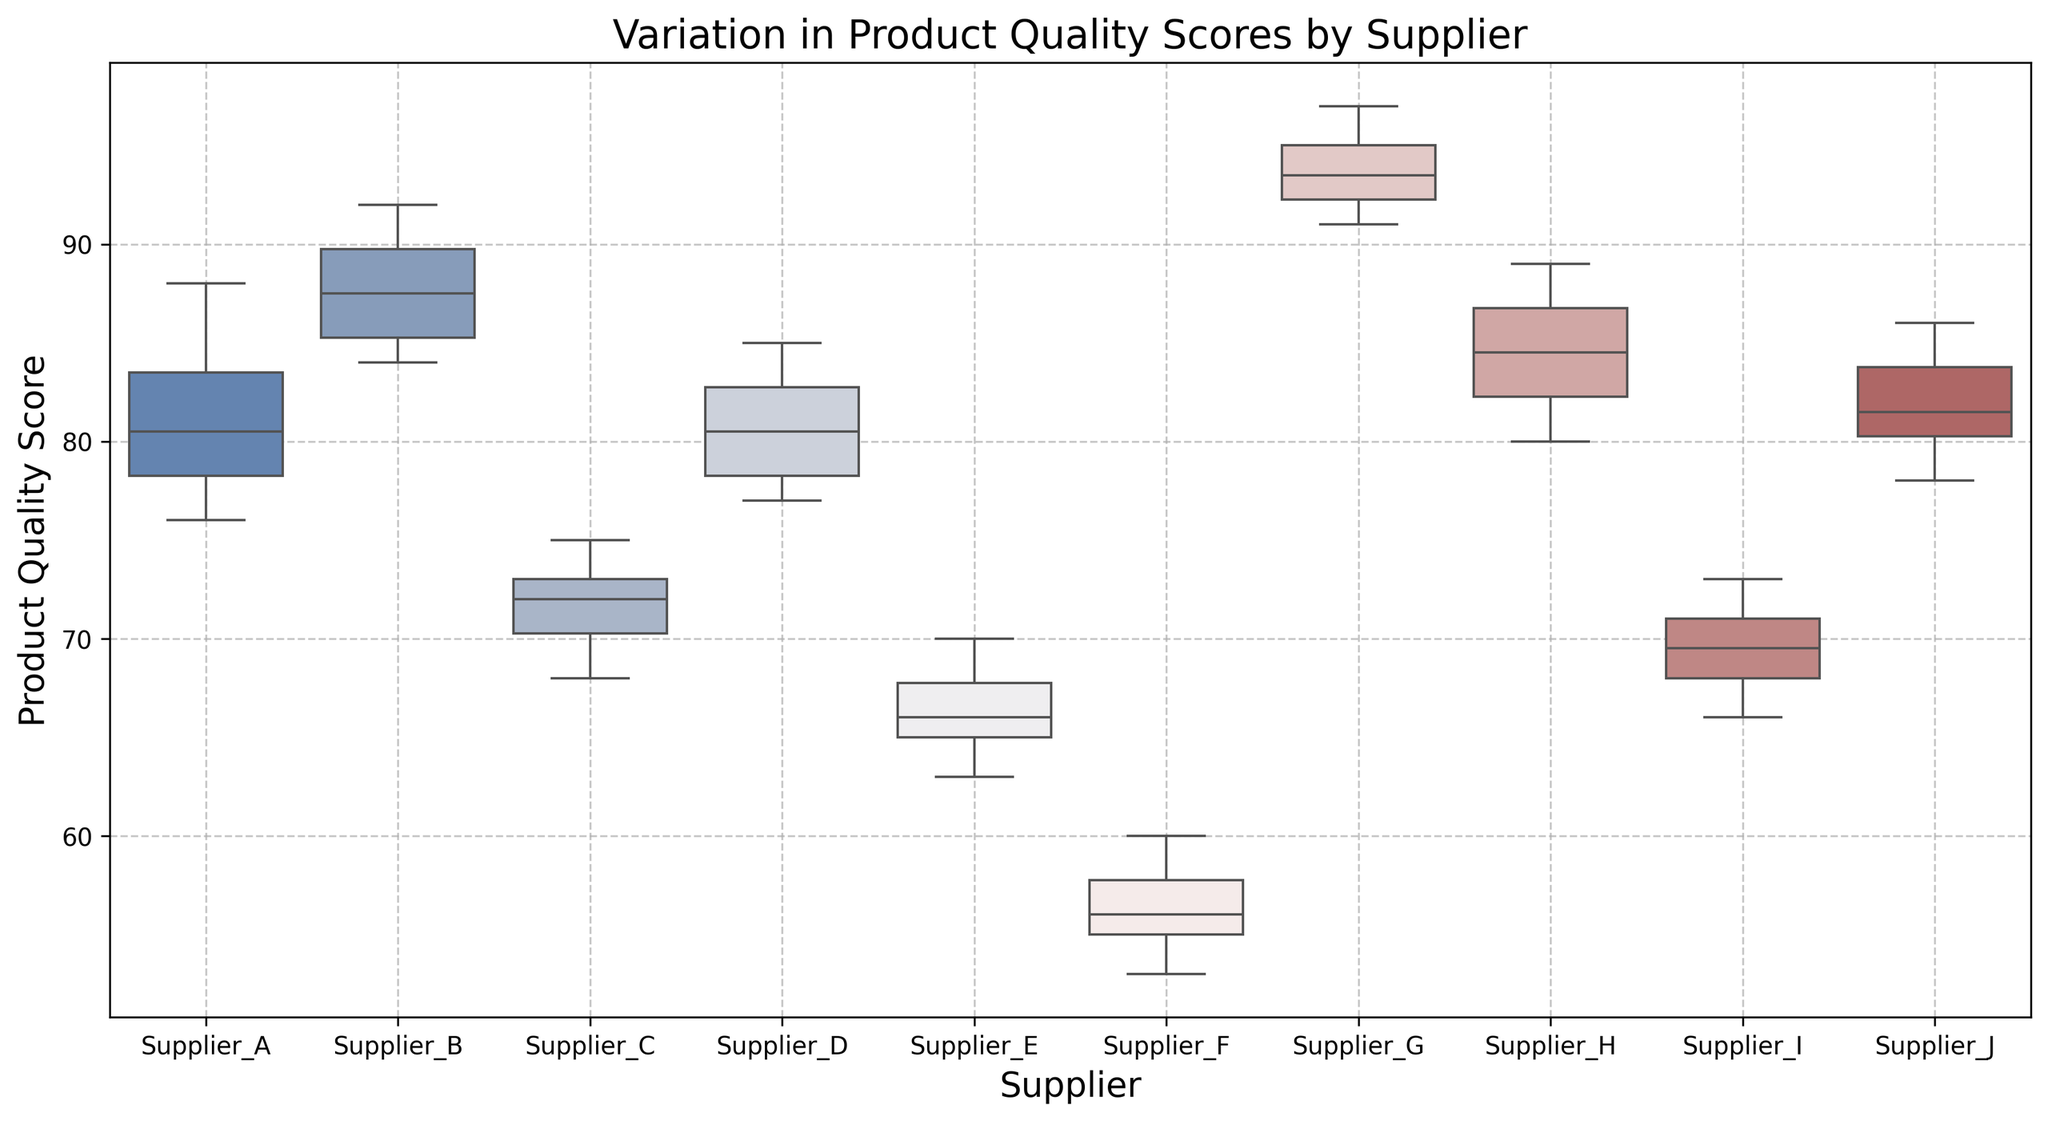Which supplier has the highest median product quality score? To find the supplier with the highest median score, look for the median lines within each box in the box plot. Supplier G’s median score line is highest among all.
Answer: Supplier G Which supplier has the lowest median product quality score? Similarly, the supplier with the lowest median score can be identified by the lowest median line. Supplier F has the lowest median score line.
Answer: Supplier F What is the interquartile range (IQR) for Supplier B? The IQR is the range between the first quartile (Q1) and the third quartile (Q3). For Supplier B, the Q1 is at 85, and Q3 is at 90. Therefore, the IQR is 90 - 85 = 5.
Answer: 5 Which supplier has the most varied quality scores? You can determine variation by looking at the length of the box and the whiskers. Supplier F shows the most variation with a wider spread between whiskers.
Answer: Supplier F Compare the median product quality scores of Supplier A and Supplier J. Which one is higher? Look at the median lines of Supplier A and Supplier J. The median line of Supplier J is at a higher value compared to Supplier A.
Answer: Supplier J Which supplier has the smallest interquartile range? The smallest IQR can be found by observing which box is the narrowest. Supplier J has the narrowest box.
Answer: Supplier J How many suppliers have median product quality scores above 80? Observe and count the median lines that are above the value 80. The suppliers are B, D, G, H, and J, totaling 5 suppliers.
Answer: 5 Which supplier has the highest maximum product quality score? The highest maximum score is represented by the upper whisker. Supplier G’s upper whisker reaches the highest point.
Answer: Supplier G How does Supplier E's product quality compare to Supplier C's in terms of median score? Compare the medians of Supplier E and Supplier C. Supplier C has a higher median than Supplier E.
Answer: Supplier C If you exclude outliers, which supplier has the lowest minimum product quality score? Excluding outliers, look for the lowest bottom whisker. Supplier F, without considering outliers, has the lowest minimum score.
Answer: Supplier F 